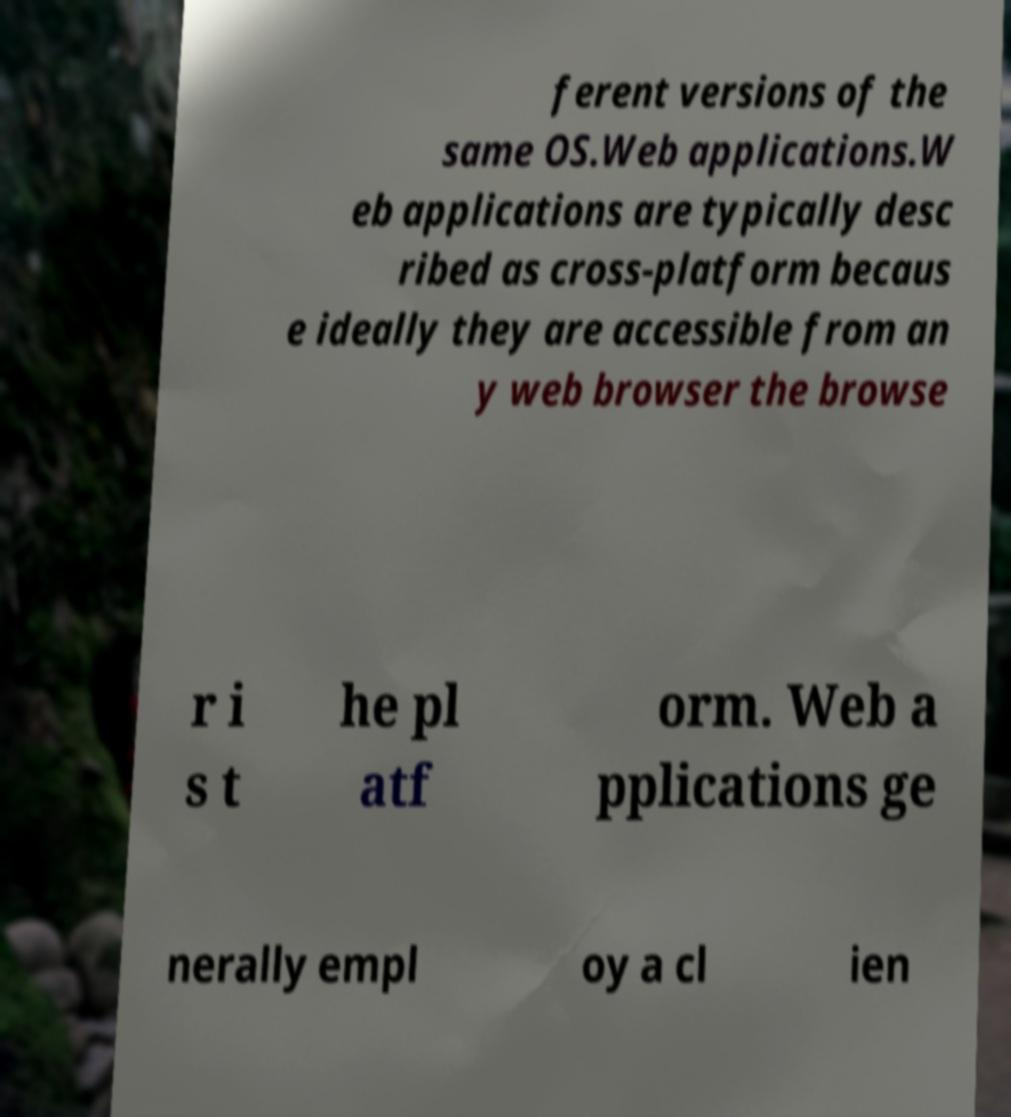Please identify and transcribe the text found in this image. ferent versions of the same OS.Web applications.W eb applications are typically desc ribed as cross-platform becaus e ideally they are accessible from an y web browser the browse r i s t he pl atf orm. Web a pplications ge nerally empl oy a cl ien 